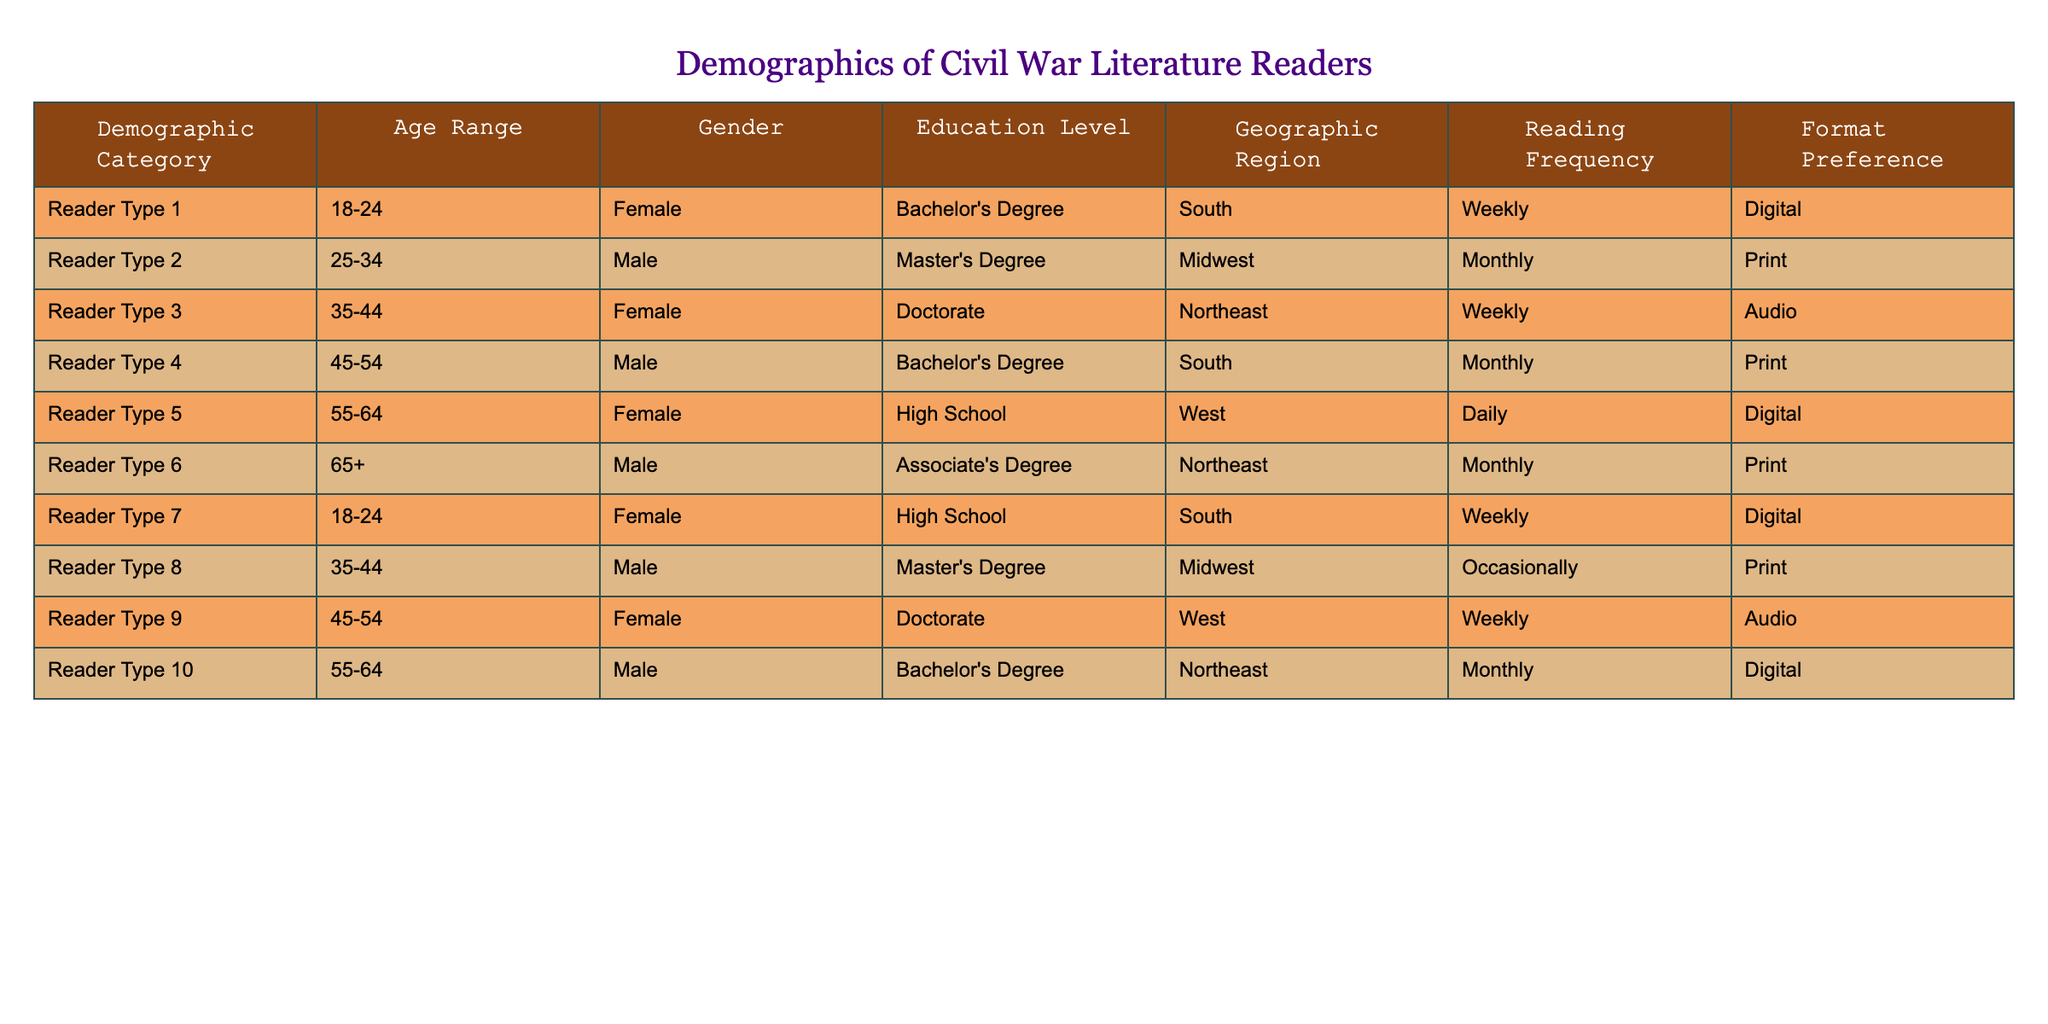What is the most common age range among readers of Civil War literature? The table lists several demographic categories with corresponding age ranges. By reviewing the data, we can see that the age range 18-24 appears twice with Reader Types 1 and 7, Age range 25-34 appears once, and the other age ranges appear less frequently or equally. Therefore, the most common age range is 18-24.
Answer: 18-24 How many female readers prefer digital formats? We can examine the "Gender" and "Format Preference" columns specifically for female readers. Reader Types 1, 5, and 7 are female, with Reader Types 1 and 7 preferring digital formats. Thus, there are two female readers who prefer digital formats.
Answer: 2 What percentage of readers in the 35-44 age group prefer audio formats? Looking at the 35-44 age group in the table, there are two readers: Reader Type 3 and Reader Type 8, with Reader Type 3 preferring audio and Reader Type 8 preferring print. To calculate the percentage, we take 1 (for audio preference) divided by 2 (total readers in that age group) and multiply by 100, resulting in 50%.
Answer: 50% Is there a gender with a higher representation in any age range? We need to analyze the age ranges for each gender in the table. The results show that the age range 18-24 has two females but only one male, while the age ranges 25-34 and 55-64 have equal representations of males and females. The age range 35-44 is balanced with one male and one female, while age range 45-54 has two females versus one male. Therefore, overall, females display higher representation in multiple age ranges, especially in 18-24 and 45-54.
Answer: Yes What is the average reading frequency for readers with a Master's Degree? In the table, the readers with a Master's Degree are Reader Types 2 and 8. Their reading frequencies are 'Monthly' and 'Occasionally'. To convert these values into numbers for averaging, we can assign Monthly a value of 1 and Occasionally a value of 0.5. Thus, the sum for these values is 1 + 0.5 = 1.5, and dividing by 2 (the number of readers) gives an average value of 0.75. When converted back to a descriptive frequency term, we can consider this close to 'Monthly'.
Answer: Monthly 